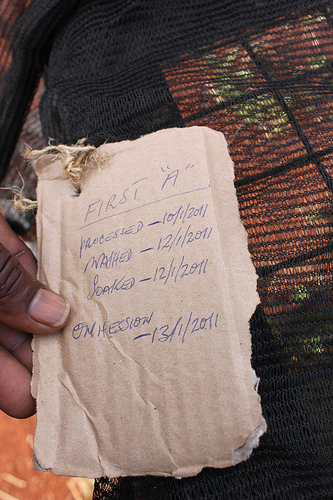<image>
Can you confirm if the mat is in the thumb? Yes. The mat is contained within or inside the thumb, showing a containment relationship. 